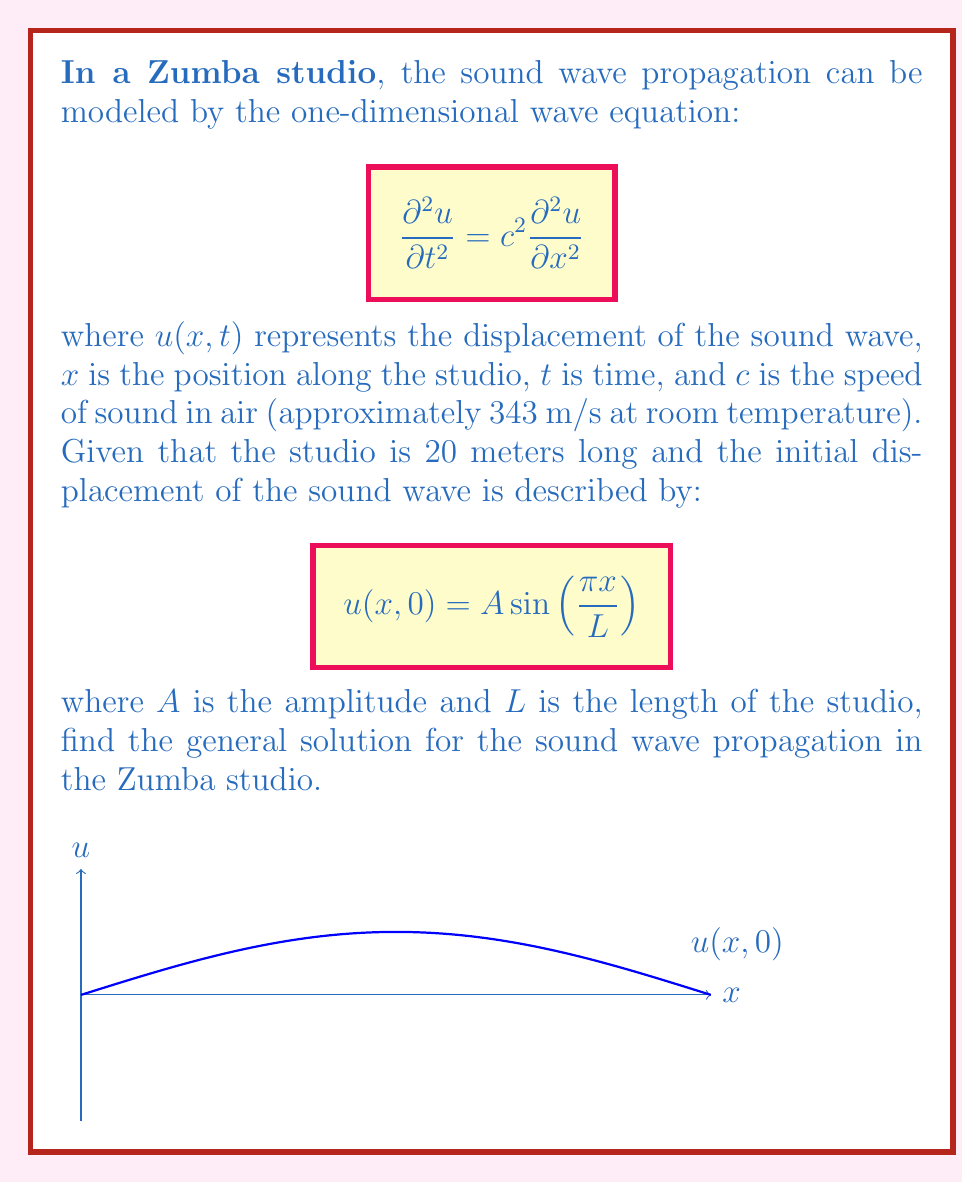Help me with this question. To solve this problem, we'll follow these steps:

1) The general solution to the one-dimensional wave equation is given by D'Alembert's formula:

   $$u(x,t) = f(x-ct) + g(x+ct)$$

   where $f$ and $g$ are arbitrary functions determined by the initial conditions.

2) Given the initial condition $u(x,0) = A \sin(\frac{\pi x}{L})$, we need to find $f$ and $g$.

3) At $t=0$, we have:

   $$u(x,0) = f(x) + g(x) = A \sin(\frac{\pi x}{L})$$

4) We also need the initial velocity condition. Assuming the initial velocity is zero (which is common for standing waves), we have:

   $$\frac{\partial u}{\partial t}(x,0) = -cf'(x) + cg'(x) = 0$$

5) From this, we can deduce that $f'(x) = g'(x)$, which means $f(x) = g(x) + constant$.

6) Using the condition from step 3 and the result from step 5:

   $$2f(x) = A \sin(\frac{\pi x}{L})$$

   $$f(x) = \frac{A}{2} \sin(\frac{\pi x}{L})$$

   $$g(x) = \frac{A}{2} \sin(\frac{\pi x}{L})$$

7) Substituting these into D'Alembert's formula:

   $$u(x,t) = \frac{A}{2} \sin(\frac{\pi (x-ct)}{L}) + \frac{A}{2} \sin(\frac{\pi (x+ct)}{L})$$

8) Using the trigonometric identity for the sum of sines, this can be simplified to:

   $$u(x,t) = A \sin(\frac{\pi x}{L}) \cos(\frac{\pi ct}{L})$$

This is the general solution for the sound wave propagation in the Zumba studio.
Answer: $$u(x,t) = A \sin(\frac{\pi x}{L}) \cos(\frac{\pi ct}{L})$$ 